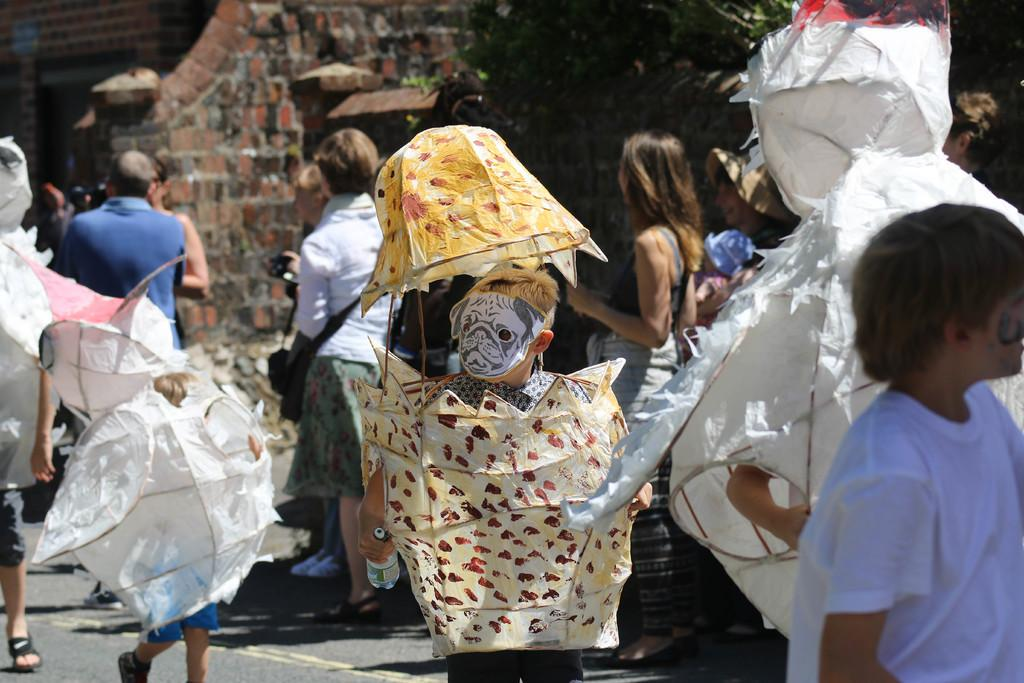How many people are in the group visible in the image? There is a group of people in the image, but the exact number cannot be determined from the provided facts. What are some people wearing in the image? Some people are wearing different costumes in the image. What is at the bottom of the image? There is a road at the bottom of the image. What can be seen in the background of the image? In the background of the image, there are brick walls, a tree, and other objects. What type of memory is being used by the people in the image? There is no information about memory usage in the image. How does the acoustics of the environment affect the people in the image? There is no information about acoustics or their effects on the people in the image. 